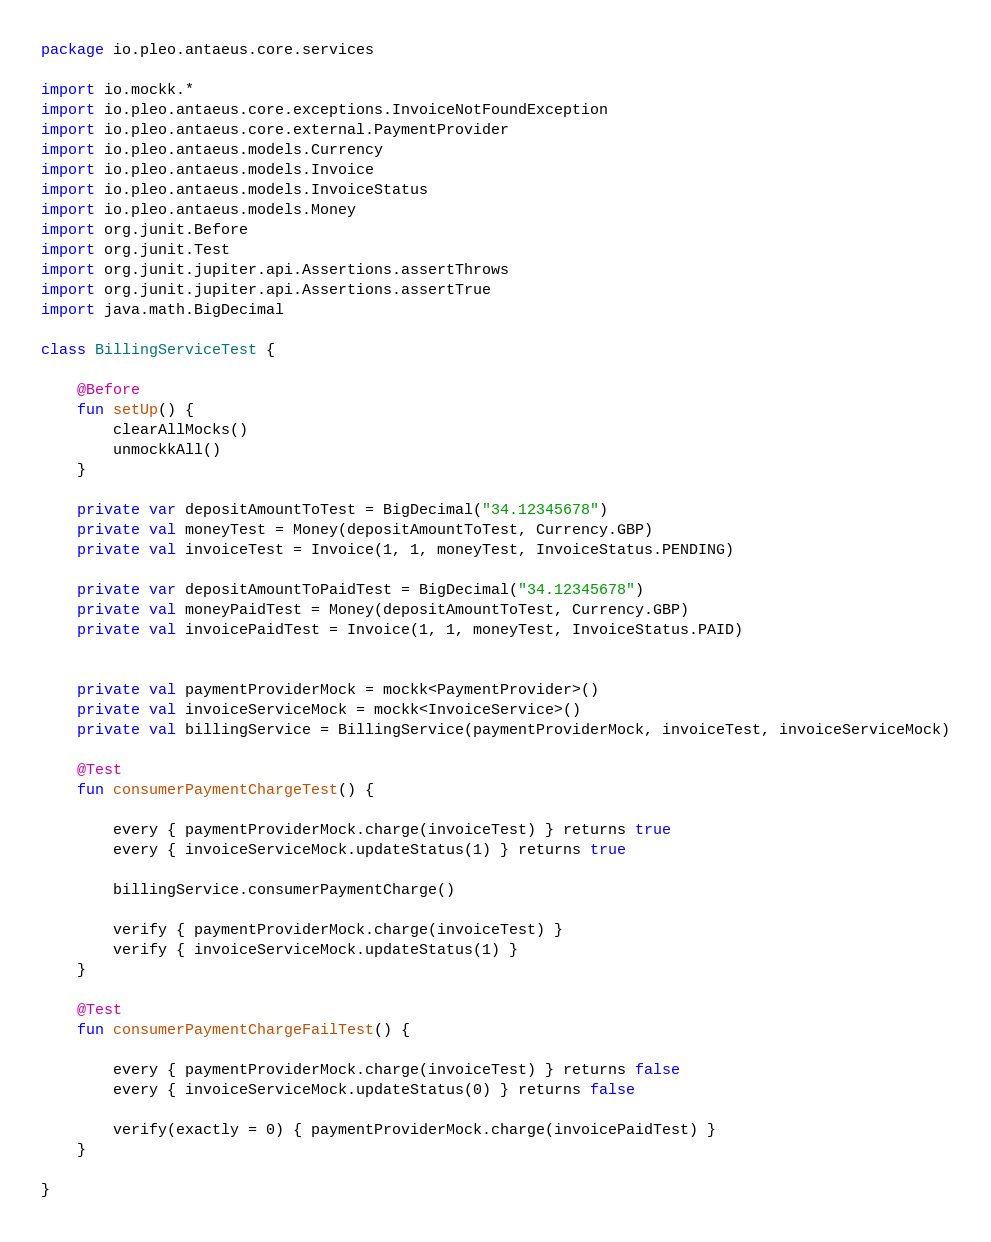<code> <loc_0><loc_0><loc_500><loc_500><_Kotlin_>package io.pleo.antaeus.core.services

import io.mockk.*
import io.pleo.antaeus.core.exceptions.InvoiceNotFoundException
import io.pleo.antaeus.core.external.PaymentProvider
import io.pleo.antaeus.models.Currency
import io.pleo.antaeus.models.Invoice
import io.pleo.antaeus.models.InvoiceStatus
import io.pleo.antaeus.models.Money
import org.junit.Before
import org.junit.Test
import org.junit.jupiter.api.Assertions.assertThrows
import org.junit.jupiter.api.Assertions.assertTrue
import java.math.BigDecimal

class BillingServiceTest {

    @Before
    fun setUp() {
        clearAllMocks()
        unmockkAll()
    }

    private var depositAmountToTest = BigDecimal("34.12345678")
    private val moneyTest = Money(depositAmountToTest, Currency.GBP)
    private val invoiceTest = Invoice(1, 1, moneyTest, InvoiceStatus.PENDING)

    private var depositAmountToPaidTest = BigDecimal("34.12345678")
    private val moneyPaidTest = Money(depositAmountToTest, Currency.GBP)
    private val invoicePaidTest = Invoice(1, 1, moneyTest, InvoiceStatus.PAID)


    private val paymentProviderMock = mockk<PaymentProvider>()
    private val invoiceServiceMock = mockk<InvoiceService>()
    private val billingService = BillingService(paymentProviderMock, invoiceTest, invoiceServiceMock)

    @Test
    fun consumerPaymentChargeTest() {

        every { paymentProviderMock.charge(invoiceTest) } returns true
        every { invoiceServiceMock.updateStatus(1) } returns true

        billingService.consumerPaymentCharge()

        verify { paymentProviderMock.charge(invoiceTest) }
        verify { invoiceServiceMock.updateStatus(1) }
    }

    @Test
    fun consumerPaymentChargeFailTest() {

        every { paymentProviderMock.charge(invoiceTest) } returns false
        every { invoiceServiceMock.updateStatus(0) } returns false

        verify(exactly = 0) { paymentProviderMock.charge(invoicePaidTest) }
    }

}</code> 